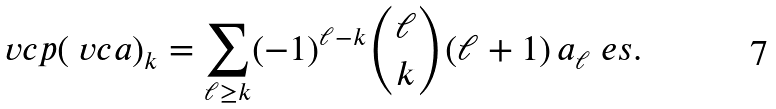Convert formula to latex. <formula><loc_0><loc_0><loc_500><loc_500>\ v c { p } ( \ v c { a } ) _ { k } = \sum _ { \ell \geq k } ( - 1 ) ^ { \ell - k } \binom { \ell } { k } ( \ell + 1 ) \, a _ { \ell } \ e s .</formula> 